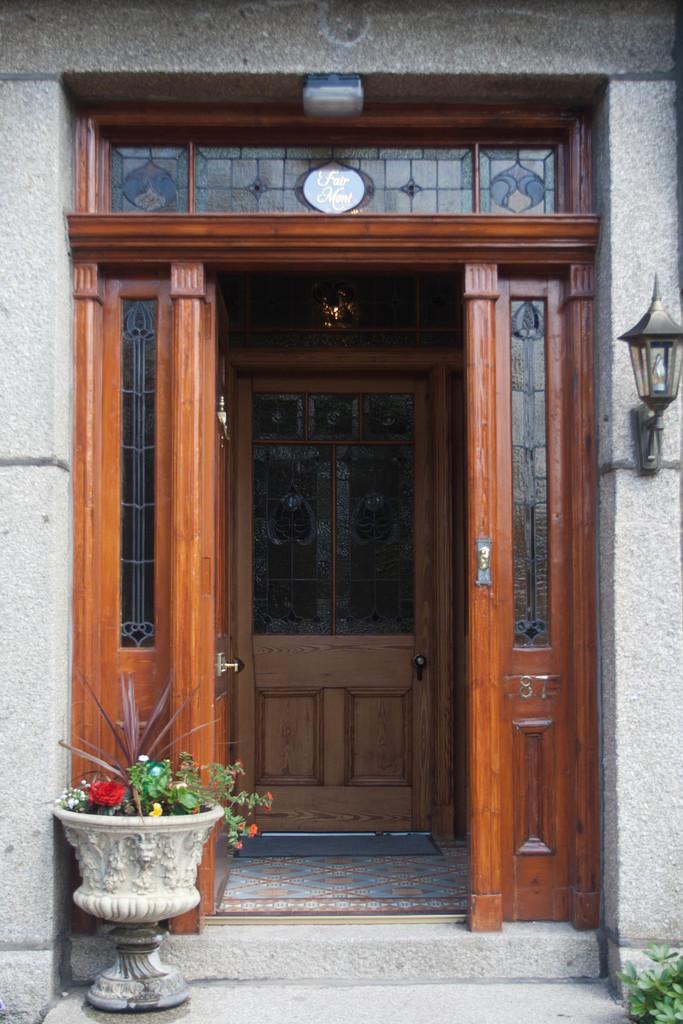Could you give a brief overview of what you see in this image? In this picture we can see flowers, plants, pot and doors. We can see light attached to the wall and mat on the floor. 